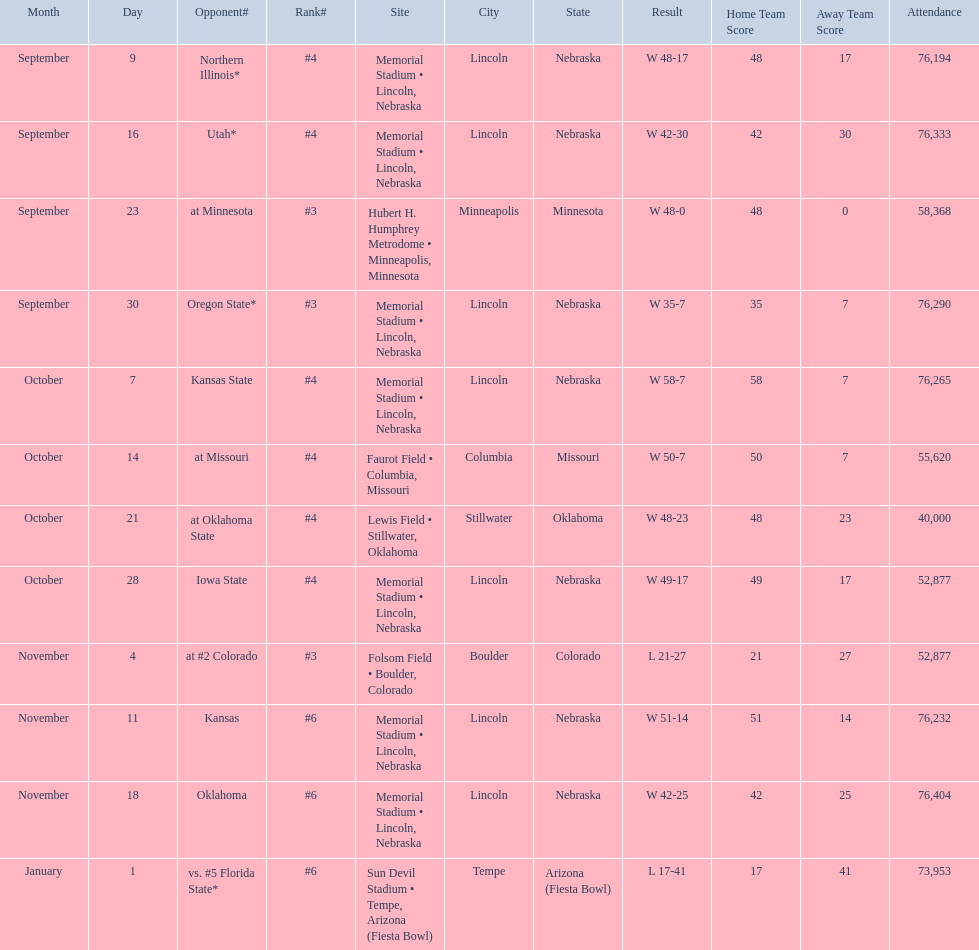Which opponenets did the nebraska cornhuskers score fewer than 40 points against? Oregon State*, at #2 Colorado, vs. #5 Florida State*. Of these games, which ones had an attendance of greater than 70,000? Oregon State*, vs. #5 Florida State*. Which of these opponents did they beat? Oregon State*. How many people were in attendance at that game? 76,290. 